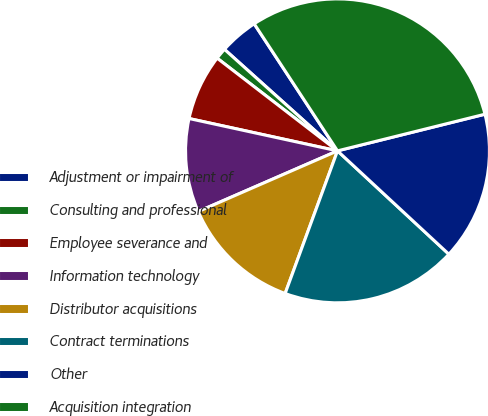Convert chart. <chart><loc_0><loc_0><loc_500><loc_500><pie_chart><fcel>Adjustment or impairment of<fcel>Consulting and professional<fcel>Employee severance and<fcel>Information technology<fcel>Distributor acquisitions<fcel>Contract terminations<fcel>Other<fcel>Acquisition integration<nl><fcel>4.12%<fcel>1.2%<fcel>7.03%<fcel>9.95%<fcel>12.86%<fcel>18.69%<fcel>15.78%<fcel>30.35%<nl></chart> 